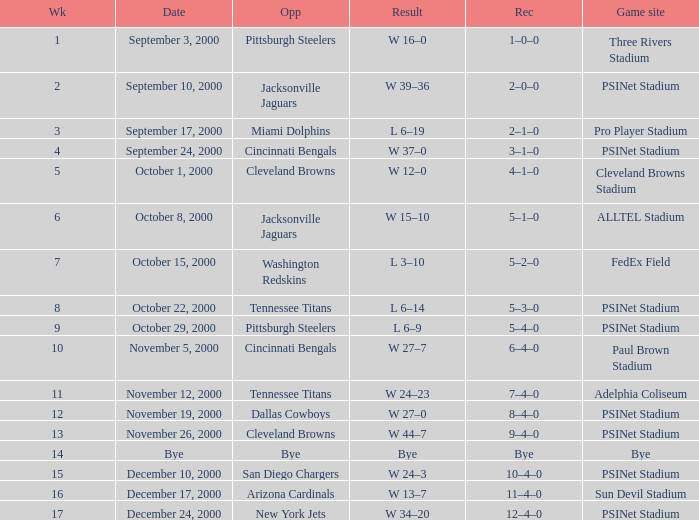What's the record after week 12 with a game site of bye? Bye. 